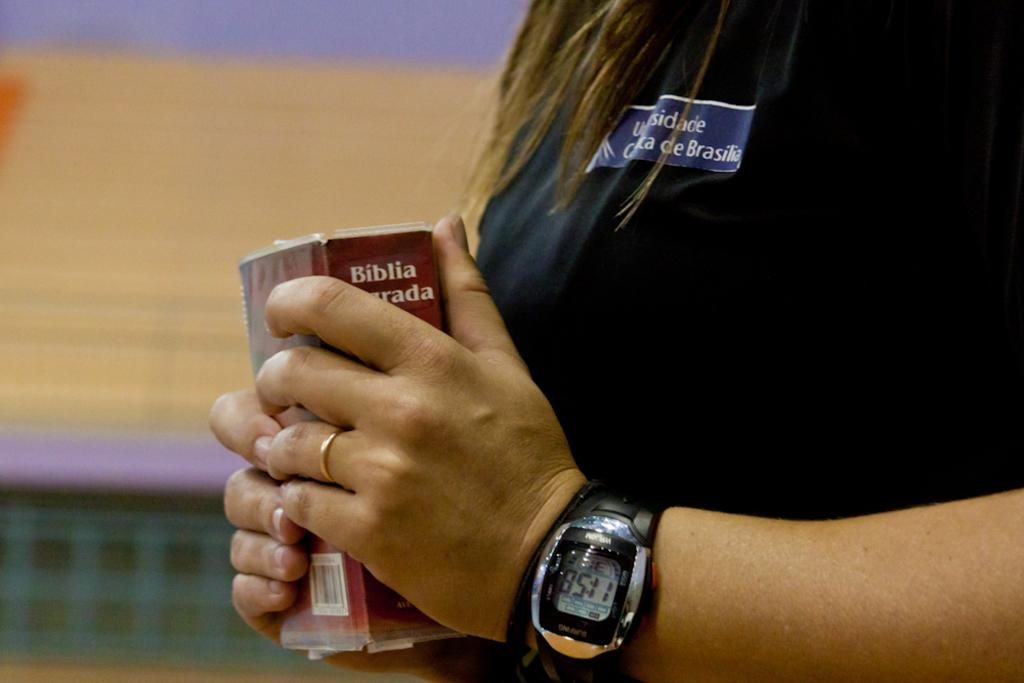<image>
Create a compact narrative representing the image presented. A woman wearing a digital watch and plain gold wedding band holds a bible in both hands. 